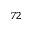<formula> <loc_0><loc_0><loc_500><loc_500>^ { 7 2 }</formula> 